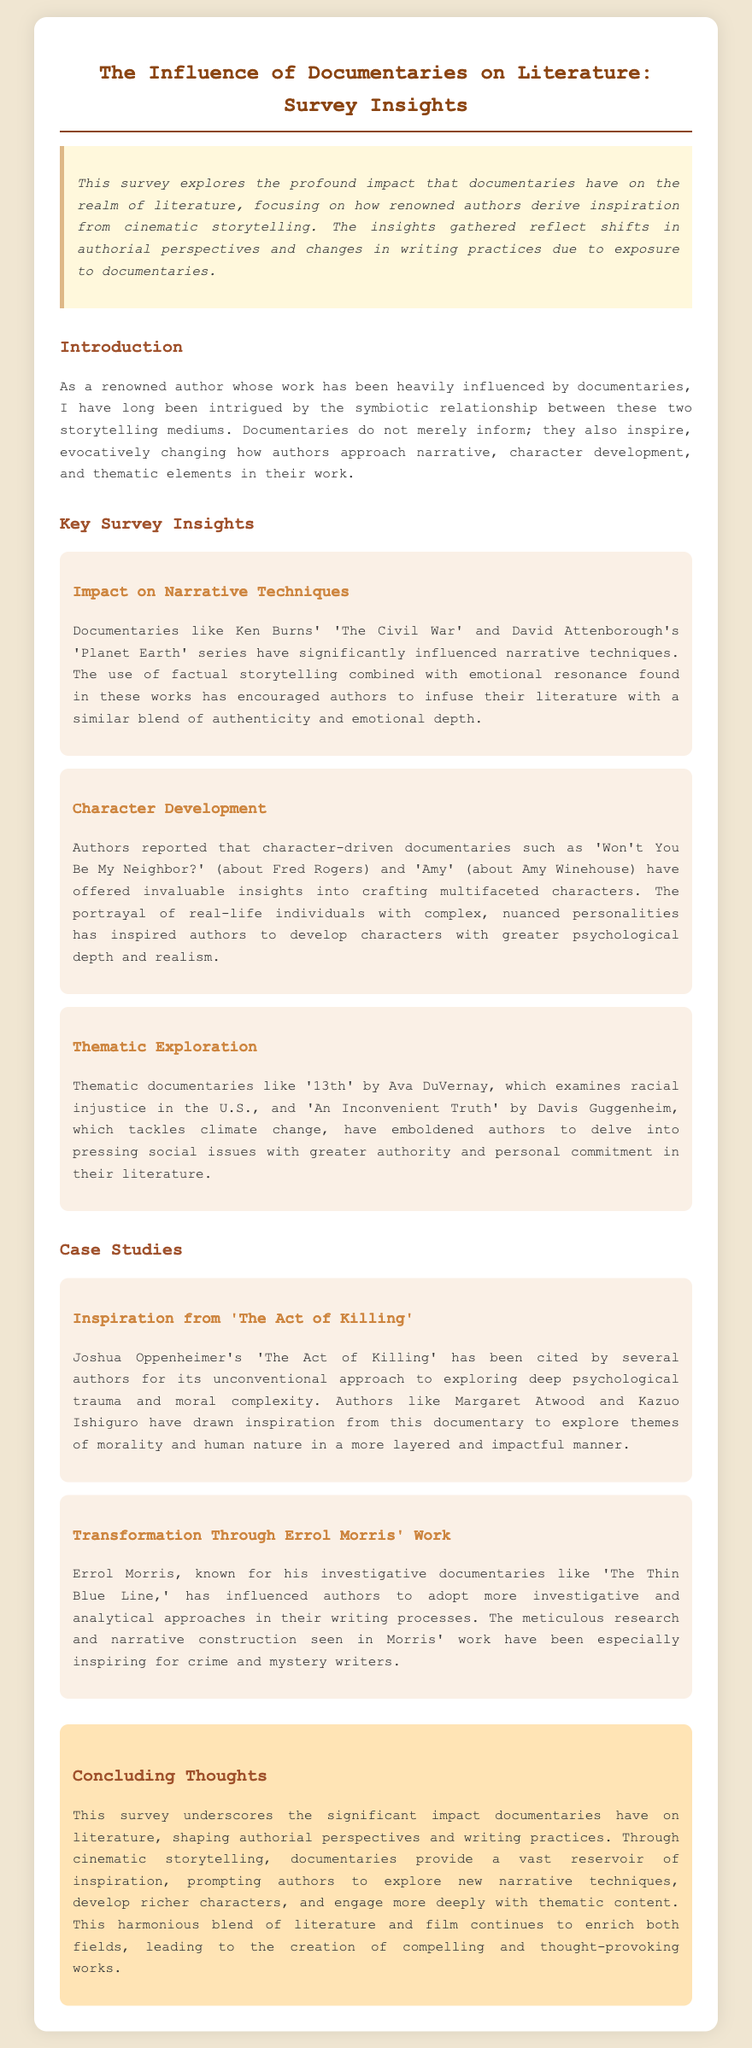What is the title of the documentary series by Ken Burns mentioned? The documentary series mentioned is 'The Civil War.'
Answer: 'The Civil War' Which author cited inspiration from 'The Act of Killing'? The document mentions that authors like Margaret Atwood have drawn inspiration from 'The Act of Killing.'
Answer: Margaret Atwood What theme is explored in Ava DuVernay's documentary '13th'? The theme explored in '13th' is racial injustice in the U.S.
Answer: racial injustice How did Errol Morris influence writing approaches? Errol Morris influenced authors to adopt more investigative and analytical approaches.
Answer: investigative and analytical What type of insights do character-driven documentaries provide? Character-driven documentaries offer insights into crafting multifaceted characters.
Answer: multifaceted characters 